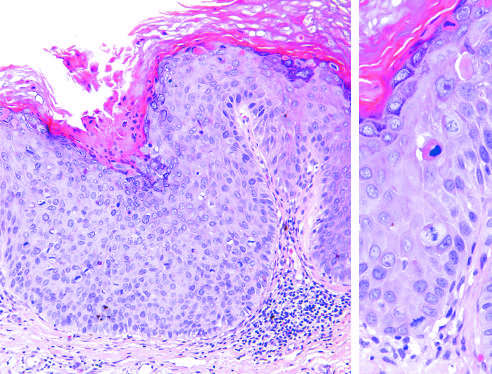does the lower lobe show delayed maturation and disorganization?
Answer the question using a single word or phrase. No 